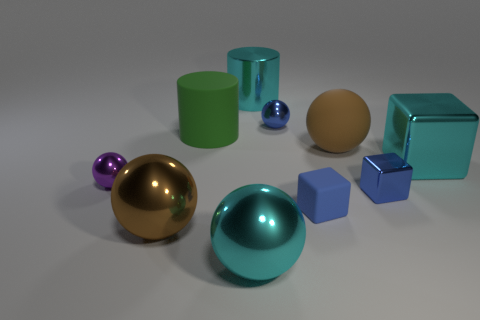How many things are big cyan shiny things or big balls that are behind the big cyan shiny sphere?
Make the answer very short. 5. The big object that is left of the cyan metal sphere and behind the blue shiny cube is made of what material?
Keep it short and to the point. Rubber. There is a cyan thing to the right of the tiny matte object; what is its material?
Provide a succinct answer. Metal. There is a big cylinder that is the same material as the cyan sphere; what color is it?
Your answer should be compact. Cyan. There is a brown metallic object; does it have the same shape as the brown thing on the right side of the big cyan metallic cylinder?
Provide a short and direct response. Yes. There is a rubber cube; are there any brown matte spheres in front of it?
Your response must be concise. No. What is the material of the other block that is the same color as the tiny metal cube?
Give a very brief answer. Rubber. Does the metal cylinder have the same size as the blue thing that is behind the green rubber object?
Your answer should be compact. No. Is there a big matte thing of the same color as the tiny metallic cube?
Make the answer very short. No. Are there any tiny blue rubber things that have the same shape as the big green thing?
Keep it short and to the point. No. 